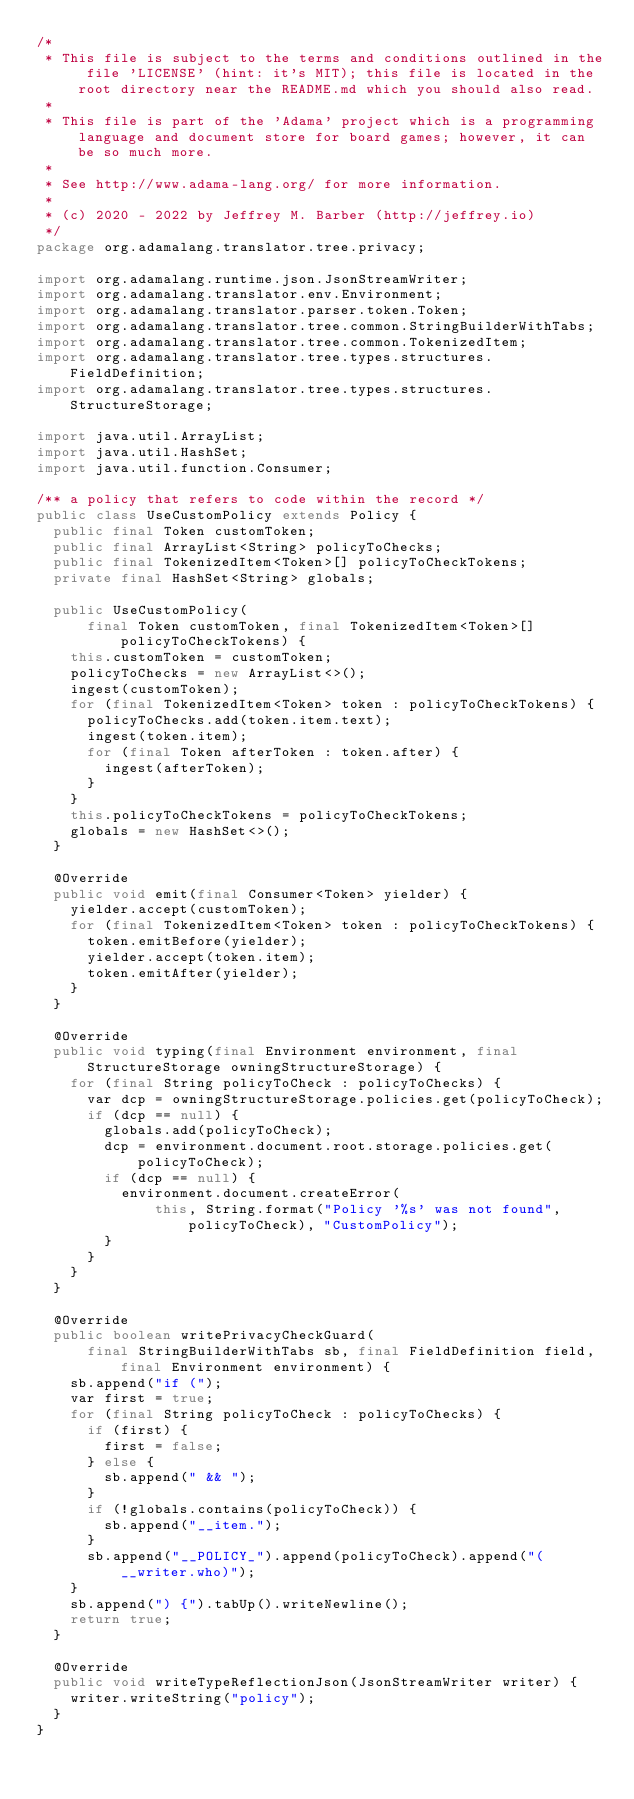<code> <loc_0><loc_0><loc_500><loc_500><_Java_>/*
 * This file is subject to the terms and conditions outlined in the file 'LICENSE' (hint: it's MIT); this file is located in the root directory near the README.md which you should also read.
 *
 * This file is part of the 'Adama' project which is a programming language and document store for board games; however, it can be so much more.
 *
 * See http://www.adama-lang.org/ for more information.
 *
 * (c) 2020 - 2022 by Jeffrey M. Barber (http://jeffrey.io)
 */
package org.adamalang.translator.tree.privacy;

import org.adamalang.runtime.json.JsonStreamWriter;
import org.adamalang.translator.env.Environment;
import org.adamalang.translator.parser.token.Token;
import org.adamalang.translator.tree.common.StringBuilderWithTabs;
import org.adamalang.translator.tree.common.TokenizedItem;
import org.adamalang.translator.tree.types.structures.FieldDefinition;
import org.adamalang.translator.tree.types.structures.StructureStorage;

import java.util.ArrayList;
import java.util.HashSet;
import java.util.function.Consumer;

/** a policy that refers to code within the record */
public class UseCustomPolicy extends Policy {
  public final Token customToken;
  public final ArrayList<String> policyToChecks;
  public final TokenizedItem<Token>[] policyToCheckTokens;
  private final HashSet<String> globals;

  public UseCustomPolicy(
      final Token customToken, final TokenizedItem<Token>[] policyToCheckTokens) {
    this.customToken = customToken;
    policyToChecks = new ArrayList<>();
    ingest(customToken);
    for (final TokenizedItem<Token> token : policyToCheckTokens) {
      policyToChecks.add(token.item.text);
      ingest(token.item);
      for (final Token afterToken : token.after) {
        ingest(afterToken);
      }
    }
    this.policyToCheckTokens = policyToCheckTokens;
    globals = new HashSet<>();
  }

  @Override
  public void emit(final Consumer<Token> yielder) {
    yielder.accept(customToken);
    for (final TokenizedItem<Token> token : policyToCheckTokens) {
      token.emitBefore(yielder);
      yielder.accept(token.item);
      token.emitAfter(yielder);
    }
  }

  @Override
  public void typing(final Environment environment, final StructureStorage owningStructureStorage) {
    for (final String policyToCheck : policyToChecks) {
      var dcp = owningStructureStorage.policies.get(policyToCheck);
      if (dcp == null) {
        globals.add(policyToCheck);
        dcp = environment.document.root.storage.policies.get(policyToCheck);
        if (dcp == null) {
          environment.document.createError(
              this, String.format("Policy '%s' was not found", policyToCheck), "CustomPolicy");
        }
      }
    }
  }

  @Override
  public boolean writePrivacyCheckGuard(
      final StringBuilderWithTabs sb, final FieldDefinition field, final Environment environment) {
    sb.append("if (");
    var first = true;
    for (final String policyToCheck : policyToChecks) {
      if (first) {
        first = false;
      } else {
        sb.append(" && ");
      }
      if (!globals.contains(policyToCheck)) {
        sb.append("__item.");
      }
      sb.append("__POLICY_").append(policyToCheck).append("(__writer.who)");
    }
    sb.append(") {").tabUp().writeNewline();
    return true;
  }

  @Override
  public void writeTypeReflectionJson(JsonStreamWriter writer) {
    writer.writeString("policy");
  }
}
</code> 